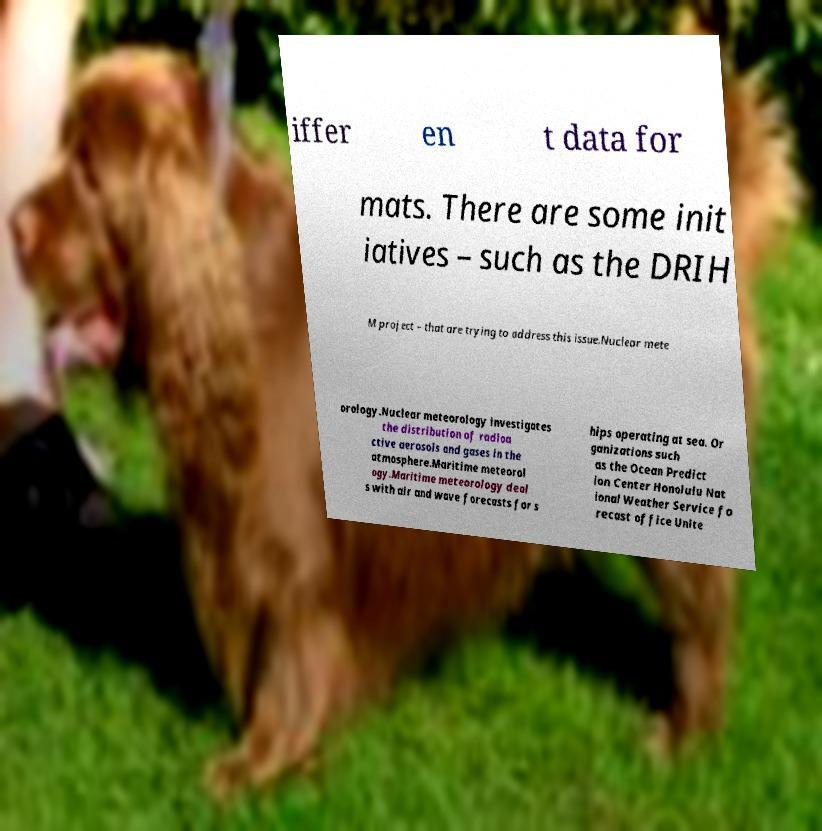What messages or text are displayed in this image? I need them in a readable, typed format. iffer en t data for mats. There are some init iatives – such as the DRIH M project – that are trying to address this issue.Nuclear mete orology.Nuclear meteorology investigates the distribution of radioa ctive aerosols and gases in the atmosphere.Maritime meteorol ogy.Maritime meteorology deal s with air and wave forecasts for s hips operating at sea. Or ganizations such as the Ocean Predict ion Center Honolulu Nat ional Weather Service fo recast office Unite 